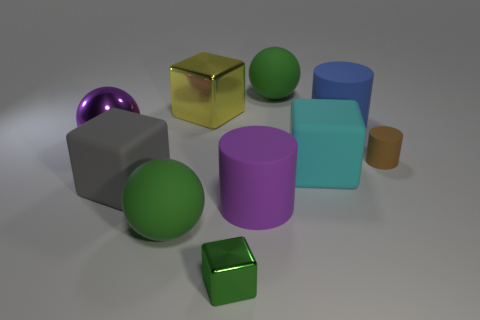How many green things are either metallic things or rubber things?
Your answer should be very brief. 3. Are there any spheres on the right side of the purple metallic ball?
Keep it short and to the point. Yes. What size is the yellow block?
Offer a very short reply. Large. There is a brown matte thing that is the same shape as the large blue matte thing; what size is it?
Provide a short and direct response. Small. There is a large object to the left of the gray rubber thing; how many gray rubber blocks are behind it?
Keep it short and to the point. 0. Does the tiny object to the right of the big blue cylinder have the same material as the sphere that is in front of the large purple metallic sphere?
Your answer should be compact. Yes. How many big purple rubber things are the same shape as the yellow object?
Your answer should be very brief. 0. How many things have the same color as the small metallic block?
Offer a terse response. 2. There is a purple object that is left of the big metallic block; is its shape the same as the green metal thing in front of the large gray matte cube?
Offer a very short reply. No. There is a green ball that is in front of the large matte ball that is behind the tiny brown rubber object; what number of purple rubber cylinders are in front of it?
Give a very brief answer. 0. 